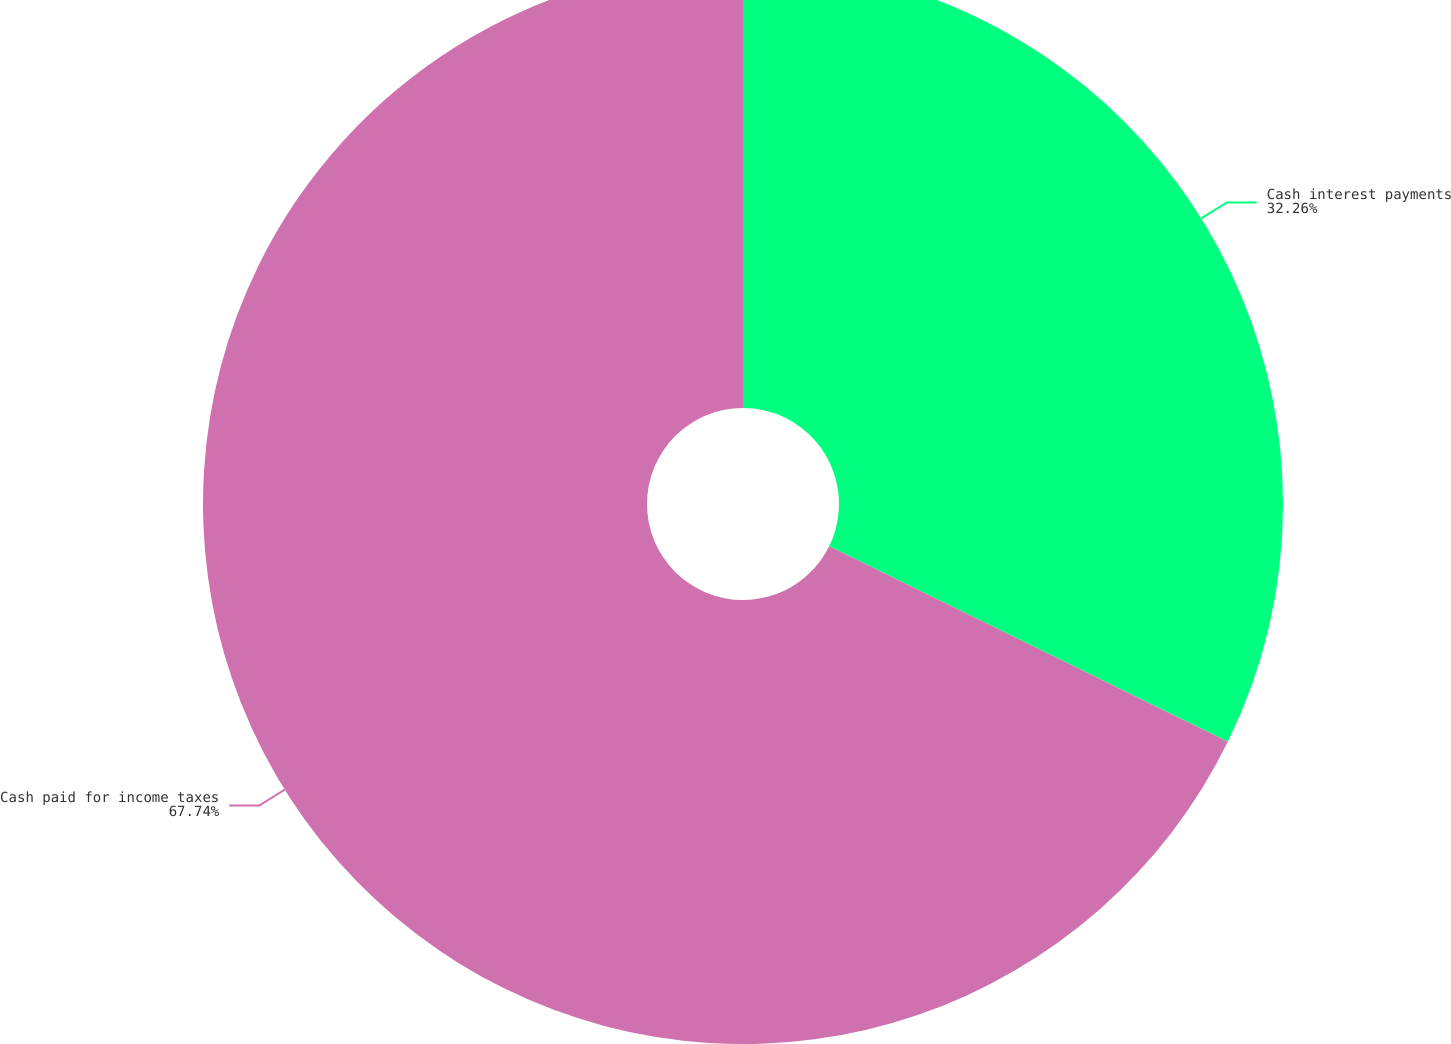<chart> <loc_0><loc_0><loc_500><loc_500><pie_chart><fcel>Cash interest payments<fcel>Cash paid for income taxes<nl><fcel>32.26%<fcel>67.74%<nl></chart> 